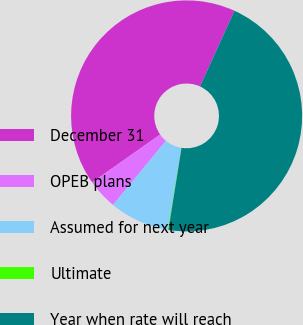Convert chart. <chart><loc_0><loc_0><loc_500><loc_500><pie_chart><fcel>December 31<fcel>OPEB plans<fcel>Assumed for next year<fcel>Ultimate<fcel>Year when rate will reach<nl><fcel>41.56%<fcel>4.24%<fcel>8.4%<fcel>0.08%<fcel>45.72%<nl></chart> 